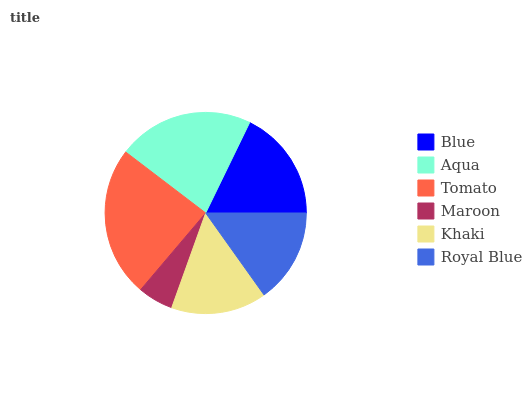Is Maroon the minimum?
Answer yes or no. Yes. Is Tomato the maximum?
Answer yes or no. Yes. Is Aqua the minimum?
Answer yes or no. No. Is Aqua the maximum?
Answer yes or no. No. Is Aqua greater than Blue?
Answer yes or no. Yes. Is Blue less than Aqua?
Answer yes or no. Yes. Is Blue greater than Aqua?
Answer yes or no. No. Is Aqua less than Blue?
Answer yes or no. No. Is Blue the high median?
Answer yes or no. Yes. Is Khaki the low median?
Answer yes or no. Yes. Is Maroon the high median?
Answer yes or no. No. Is Royal Blue the low median?
Answer yes or no. No. 